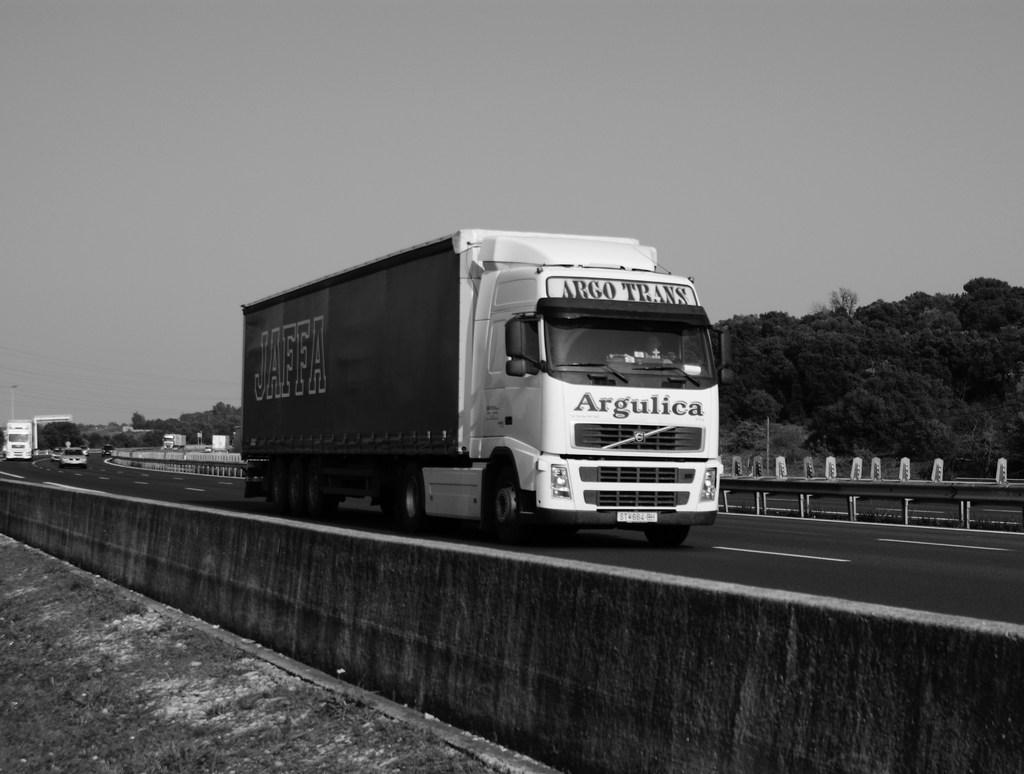What can be seen on the road in the image? There are vehicles on the road in the image. What type of natural elements are visible in the image? There are trees visible in the image. What type of barrier is present in the image? There is fencing in the image. How is the image presented in terms of color? The image is in black and white. Can you tell me which page of the book the pet is on in the image? There is no book or pet present in the image. What type of sister is shown interacting with the fencing in the image? There is no sister present in the image; only vehicles, trees, and fencing are visible. 